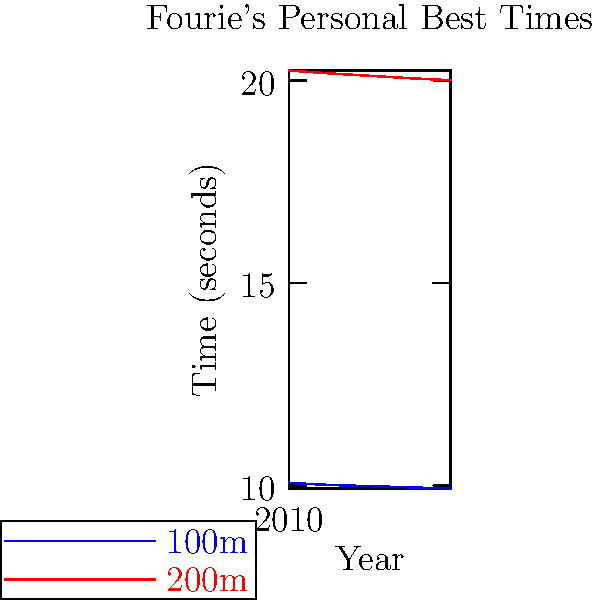Based on the graph showing Fourie's personal best times in the 100m and 200m events from 2010 to 2014, what was the improvement in his 100m time over this period? To determine Fourie's improvement in the 100m event from 2010 to 2014, we need to:

1. Identify his 100m time in 2010: 10.06 seconds
2. Identify his 100m time in 2014: 9.92 seconds
3. Calculate the difference:
   
   $10.06 - 9.92 = 0.14$ seconds

The graph shows a consistent improvement in Fourie's 100m times over the years, with his personal best dropping from 10.06 seconds in 2010 to 9.92 seconds in 2014. This represents a total improvement of 0.14 seconds over the five-year period.

It's worth noting that in sprinting events, an improvement of 0.14 seconds is quite significant, especially at the elite level where Fourie competes.
Answer: 0.14 seconds 